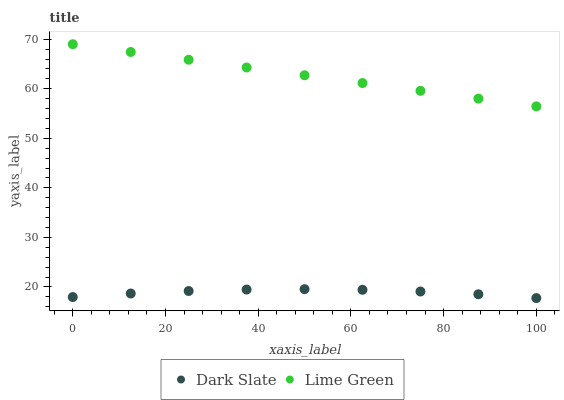Does Dark Slate have the minimum area under the curve?
Answer yes or no. Yes. Does Lime Green have the maximum area under the curve?
Answer yes or no. Yes. Does Lime Green have the minimum area under the curve?
Answer yes or no. No. Is Lime Green the smoothest?
Answer yes or no. Yes. Is Dark Slate the roughest?
Answer yes or no. Yes. Is Lime Green the roughest?
Answer yes or no. No. Does Dark Slate have the lowest value?
Answer yes or no. Yes. Does Lime Green have the lowest value?
Answer yes or no. No. Does Lime Green have the highest value?
Answer yes or no. Yes. Is Dark Slate less than Lime Green?
Answer yes or no. Yes. Is Lime Green greater than Dark Slate?
Answer yes or no. Yes. Does Dark Slate intersect Lime Green?
Answer yes or no. No. 